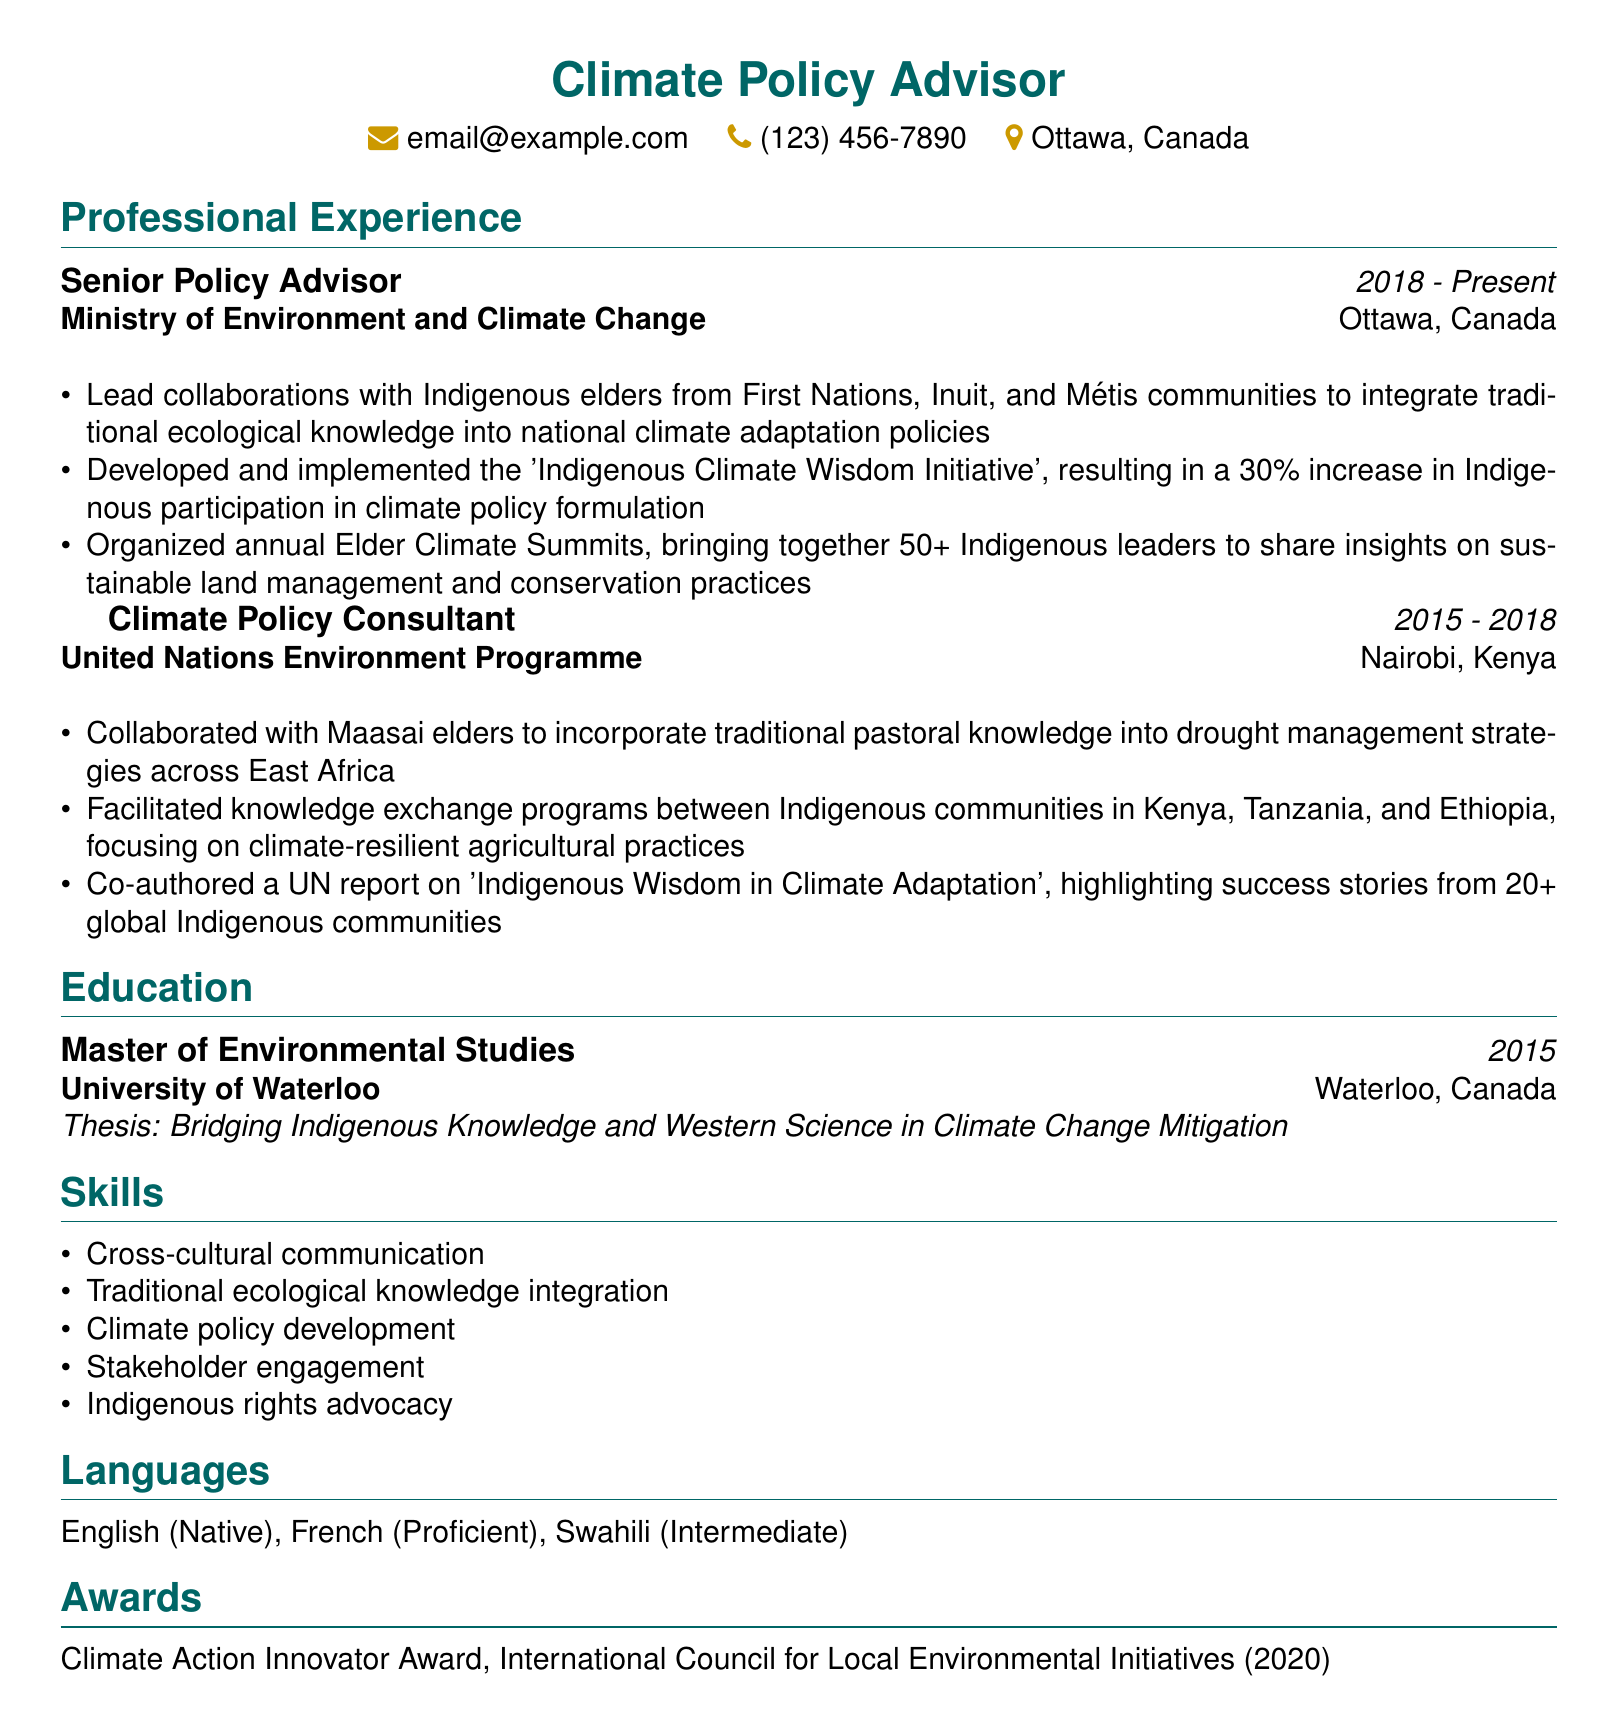what is the current position held by the individual? The current position is listed under the Professional Experience section, specifically for the years "2018 - Present".
Answer: Senior Policy Advisor which institution did the individual attend for their Master's degree? The document specifies the education history and the institution where the individual obtained their degree.
Answer: University of Waterloo what was the thesis topic of the Master's degree? The thesis topic is mentioned in the Education section under the individual's degree.
Answer: Bridging Indigenous Knowledge and Western Science in Climate Change Mitigation how many Indigenous leaders were brought together during the Elder Climate Summits? This information is given alongside the responsibilities of the Senior Policy Advisor position in the Professional Experience section.
Answer: 50+ in which year did the individual win the Climate Action Innovator Award? This award is listed in the Awards section with the corresponding year it was received.
Answer: 2020 what type of knowledge did the individual work to integrate into national climate adaptation policies? This refers to specific responsibilities under the Senior Policy Advisor role within the document.
Answer: Traditional ecological knowledge which languages does the individual speak at an intermediate level? The languages section lists the individual's proficiency levels in different languages.
Answer: Swahili what was the impact of the 'Indigenous Climate Wisdom Initiative' in terms of participation? This impact is described in the responsibilities of the Senior Policy Advisor role.
Answer: 30% increase what geographical area was focused on during the collaboration with Maasai elders? The document specifies the geographical scope of the collaboration under the Climate Policy Consultant role.
Answer: East Africa 